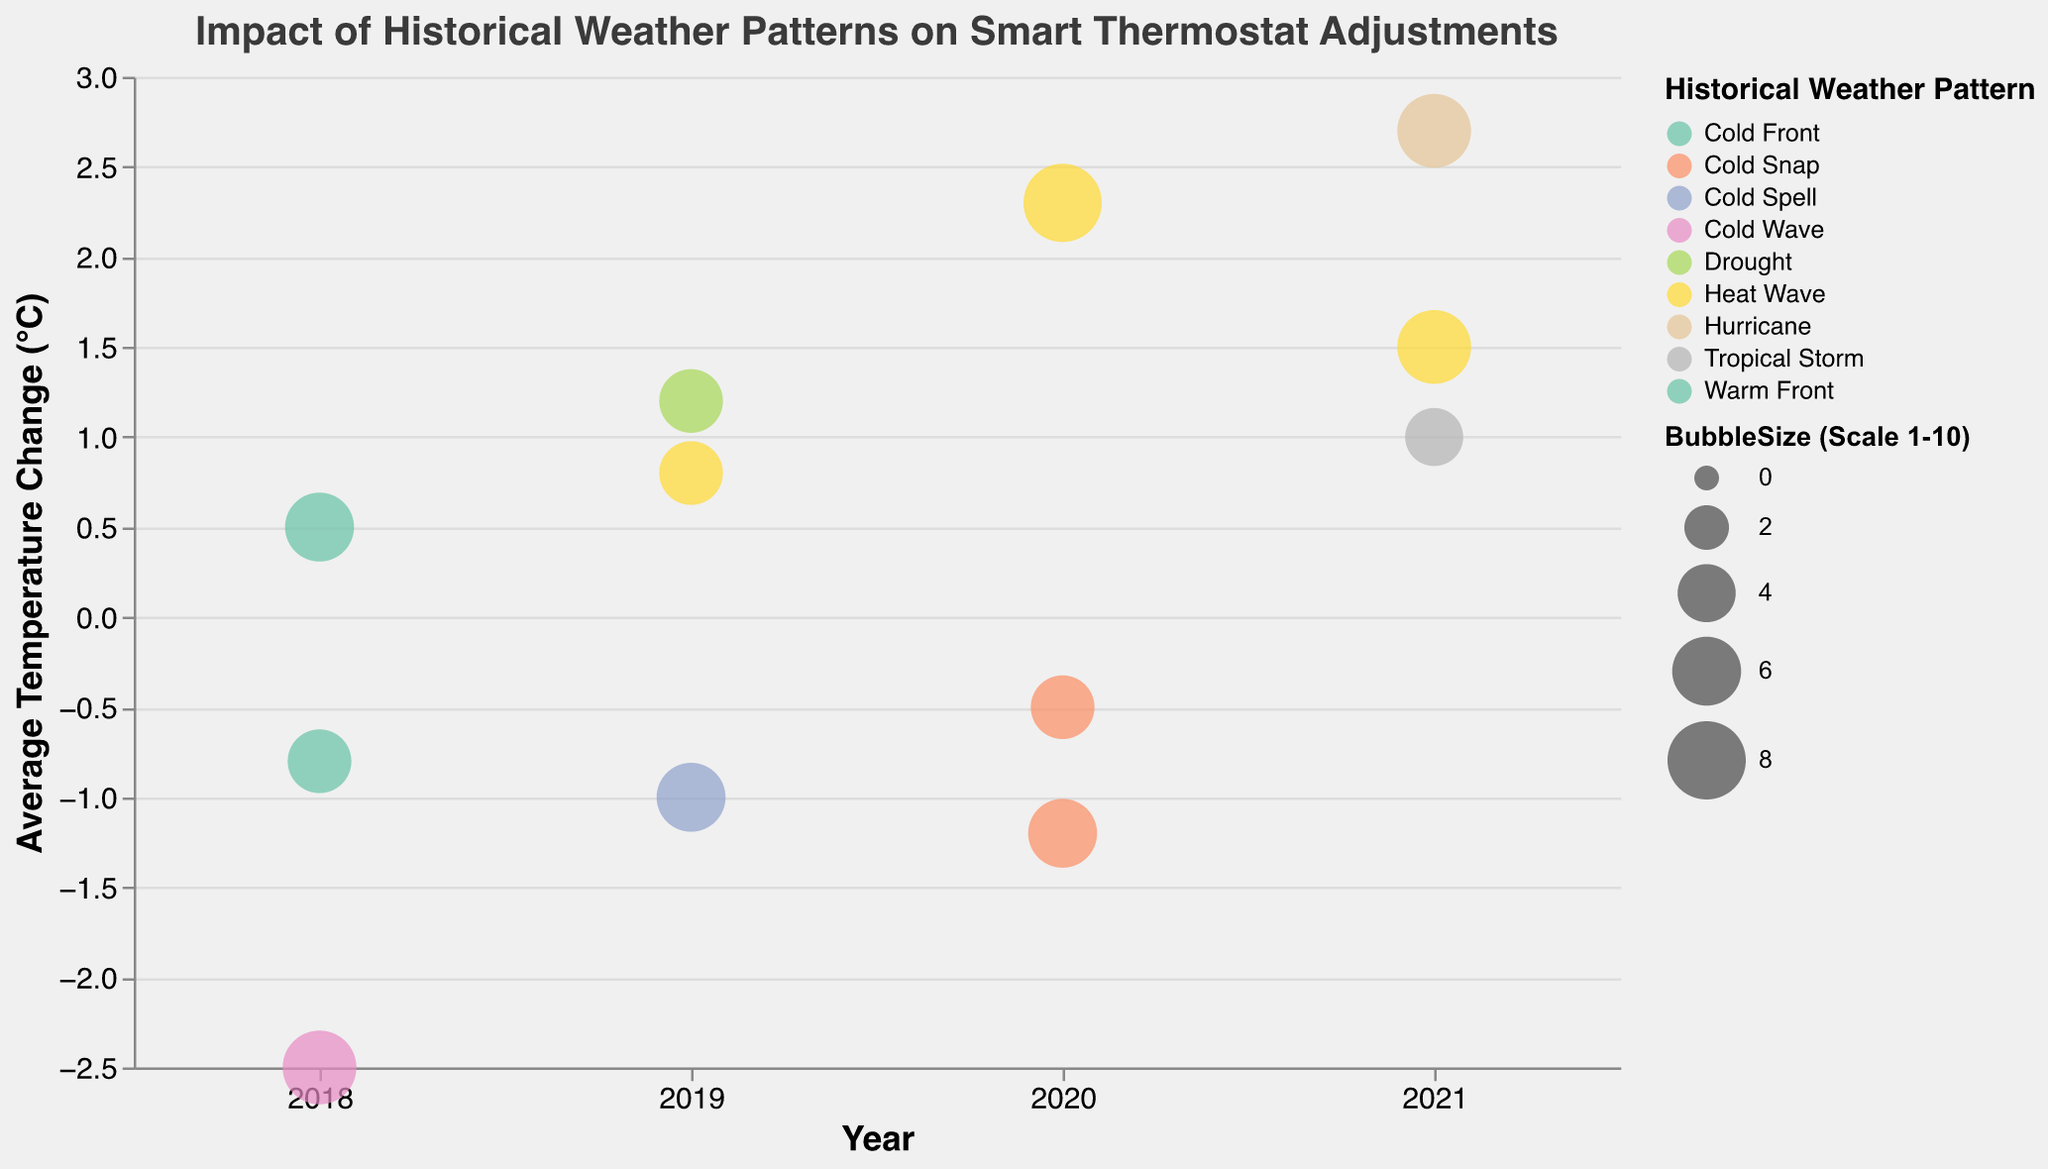What is the average temperature change experienced by Atlanta in 2020? Locate the bubble for Atlanta in 2020 on the x-axis and identify its y-axis value for "Average Temperature Change (°C)."
Answer: 2.3 Which city had the highest adjustment frequency per month in 2018? Locate the data points for 2018 and compare the "Adjustment Frequency (per month)" values. Identify the highest value and find the corresponding city.
Answer: New York How many cities experienced a heat wave between 2018 and 2021? Identify bubbles with the color representing "Heat Wave" and count them.
Answer: Three Which year had the largest number of bubbles with a negative average temperature change? Check the bubbles for each year and count those with negative y-axis values.
Answer: 2018 Compare the average temperature change between Miami in 2021 and Dallas in 2019. Which city experienced a higher change? Identify the y-axis values for Miami in 2021 and Dallas in 2019 and compare them.
Answer: Miami (2.7 vs 1.2) What is the largest bubble size scale value represented in the chart? Scan the size of bubbles and identify the largest one.
Answer: 8 Which historical weather pattern appeared most frequently in the chart? Count the occurrences of each historical weather pattern from the color legend.
Answer: Heat Wave Is the overall trend of the average temperature change increasing or decreasing from 2018 to 2021? Observe the general pattern of y-axis values from 2018 to 2021 and note if it is rising or falling.
Answer: Increasing What bubble has an adjustment frequency of 10 per month and belongs to the year 2020? Identify bubbles for 2020 and find the one which has an adjustment frequency of 10 per month.
Answer: Boston 